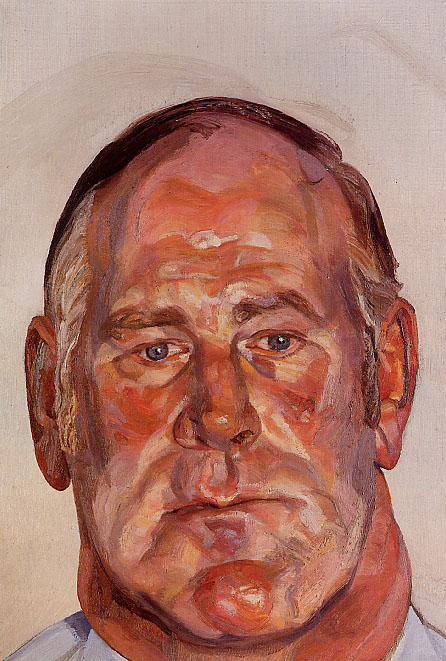Imagine this man is a character in a fantasy world. What role does he play? In a fantasy world, this man could be a wise and battle-weary sage, having spent decades fighting to protect his realm from dark forces. His weathered face, marked by the passage of time and the weight of wisdom, reflects countless tales of bravery and sacrifice. As he stands at the cusp of a great prophecy, his closed eyes indicate deep meditation, seeking clarity and guidance from ancient spirits to lead his people through the looming shadows. His vibrant appearance, laden with colors of fire and earth, symbolizes his connection to elemental magic, a power he will soon need to harness once more in the ultimate battle for peace. 